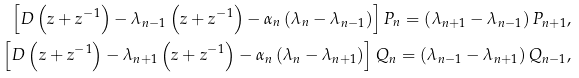<formula> <loc_0><loc_0><loc_500><loc_500>\left [ D \left ( z + z ^ { - 1 } \right ) - \lambda _ { n - 1 } \left ( z + z ^ { - 1 } \right ) - \alpha _ { n } \left ( \lambda _ { n } - \lambda _ { n - 1 } \right ) \right ] P _ { n } = \left ( \lambda _ { n + 1 } - \lambda _ { n - 1 } \right ) P _ { n + 1 } , \\ \left [ D \left ( z + z ^ { - 1 } \right ) - \lambda _ { n + 1 } \left ( z + z ^ { - 1 } \right ) - \alpha _ { n } \left ( \lambda _ { n } - \lambda _ { n + 1 } \right ) \right ] Q _ { n } = \left ( \lambda _ { n - 1 } - \lambda _ { n + 1 } \right ) Q _ { n - 1 } ,</formula> 